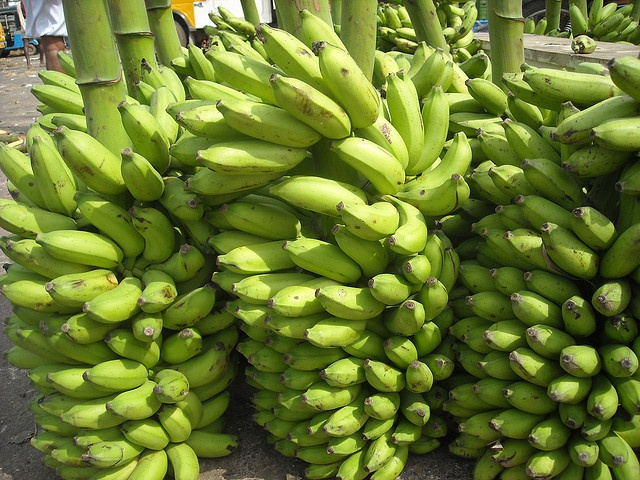Describe the objects in this image and their specific colors. I can see banana in black, darkgreen, olive, and khaki tones, banana in black, darkgreen, and olive tones, banana in black, darkgreen, and olive tones, bench in black, beige, olive, darkgray, and darkgreen tones, and people in black, darkgray, lavender, and gray tones in this image. 